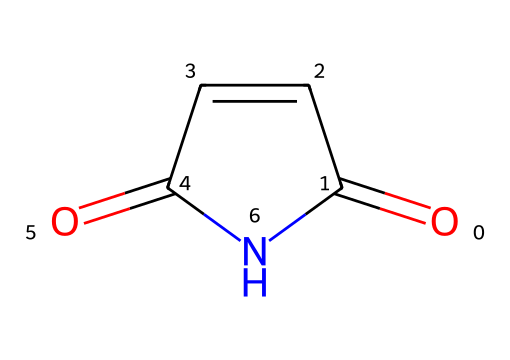What is the molecular formula of Maleimide? By analyzing the structure, we count the atoms present: there are 4 carbon atoms, 4 hydrogen atoms, 1 nitrogen atom, and 2 oxygen atoms. Putting this together gives the molecular formula C4H4N2O2.
Answer: C4H4N2O2 How many rings are present in Maleimide? The SMILES representation indicates a cyclic structure, specifically a five-membered ring containing nitrogen and carbon.
Answer: one What type of functional groups are present in Maleimide? The structure shows that Maleimide contains both imide and carbonyl functional groups. The imide group is identified by the nitrogen flanked by two carbonyls.
Answer: imide and carbonyl What is the overall symmetry of the Maleimide structure? Observing the structure, we find that Maleimide has a plane of symmetry due to the arrangement of its functional groups, which creates a balanced look.
Answer: symmetrical How does Maleimide's structure relate to Platonic ideals of symmetry? Maleimide's cyclic symmetrical structure exemplifies the Platonic ideal of forms, particularly in its balanced configuration and the harmony of its angular relationships, reminiscent of geometric perfection.
Answer: harmony of forms Does Maleimide exhibit geometric isomerism? Given the structure's lack of rigid double bonds or large steric hindrances preventing rotation or a distinct spatial arrangement, Maleimide does not exhibit geometric isomerism.
Answer: no 